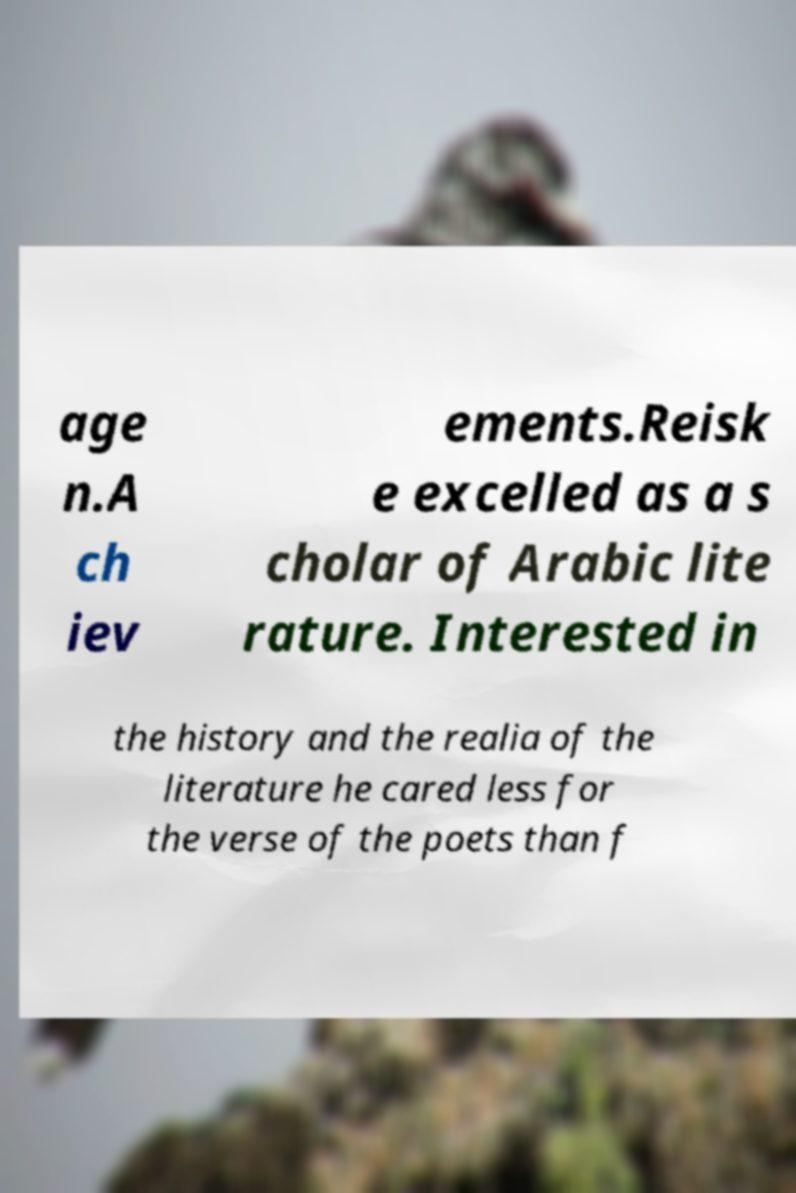I need the written content from this picture converted into text. Can you do that? age n.A ch iev ements.Reisk e excelled as a s cholar of Arabic lite rature. Interested in the history and the realia of the literature he cared less for the verse of the poets than f 